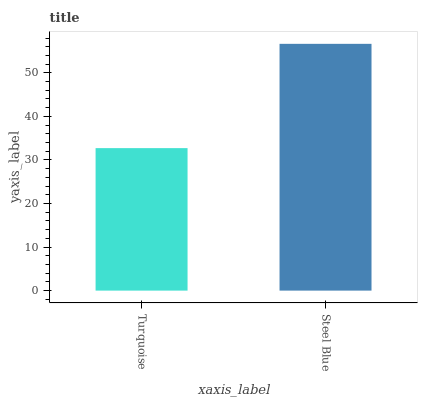Is Turquoise the minimum?
Answer yes or no. Yes. Is Steel Blue the maximum?
Answer yes or no. Yes. Is Steel Blue the minimum?
Answer yes or no. No. Is Steel Blue greater than Turquoise?
Answer yes or no. Yes. Is Turquoise less than Steel Blue?
Answer yes or no. Yes. Is Turquoise greater than Steel Blue?
Answer yes or no. No. Is Steel Blue less than Turquoise?
Answer yes or no. No. Is Steel Blue the high median?
Answer yes or no. Yes. Is Turquoise the low median?
Answer yes or no. Yes. Is Turquoise the high median?
Answer yes or no. No. Is Steel Blue the low median?
Answer yes or no. No. 